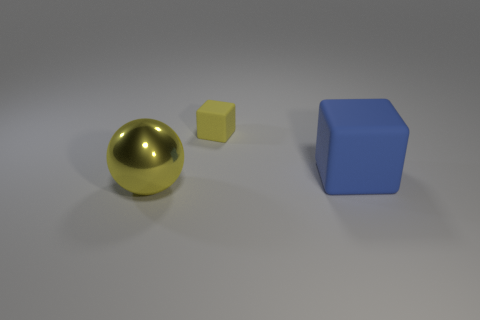Add 2 large yellow metal blocks. How many objects exist? 5 Subtract all balls. How many objects are left? 2 Subtract 0 red cylinders. How many objects are left? 3 Subtract all large blue matte cubes. Subtract all yellow things. How many objects are left? 0 Add 1 large blue rubber objects. How many large blue rubber objects are left? 2 Add 1 gray cylinders. How many gray cylinders exist? 1 